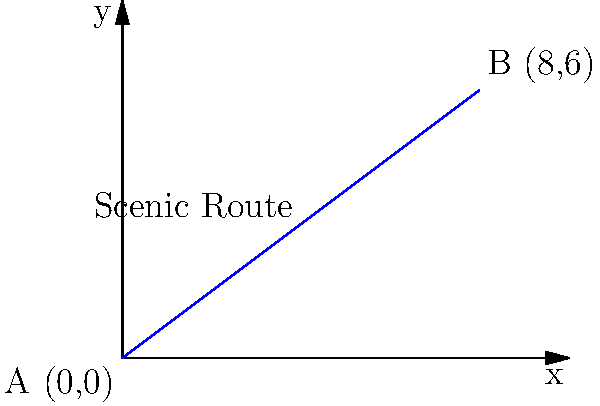As a tour guide in Khulna Division, you're planning a scenic route between two destinations. Point A represents the starting point at (0,0), and Point B represents the ending point at (8,6), where the coordinates are in kilometers. What is the slope of the line representing this scenic route? To find the slope of the line representing the scenic route, we can use the slope formula:

$$ m = \frac{y_2 - y_1}{x_2 - x_1} $$

Where $(x_1, y_1)$ is the starting point A, and $(x_2, y_2)$ is the ending point B.

Step 1: Identify the coordinates
- Point A: $(x_1, y_1) = (0, 0)$
- Point B: $(x_2, y_2) = (8, 6)$

Step 2: Plug the values into the slope formula
$$ m = \frac{y_2 - y_1}{x_2 - x_1} = \frac{6 - 0}{8 - 0} = \frac{6}{8} $$

Step 3: Simplify the fraction
$$ m = \frac{6}{8} = \frac{3}{4} = 0.75 $$

Therefore, the slope of the line representing the scenic route is $\frac{3}{4}$ or 0.75.
Answer: $\frac{3}{4}$ or 0.75 